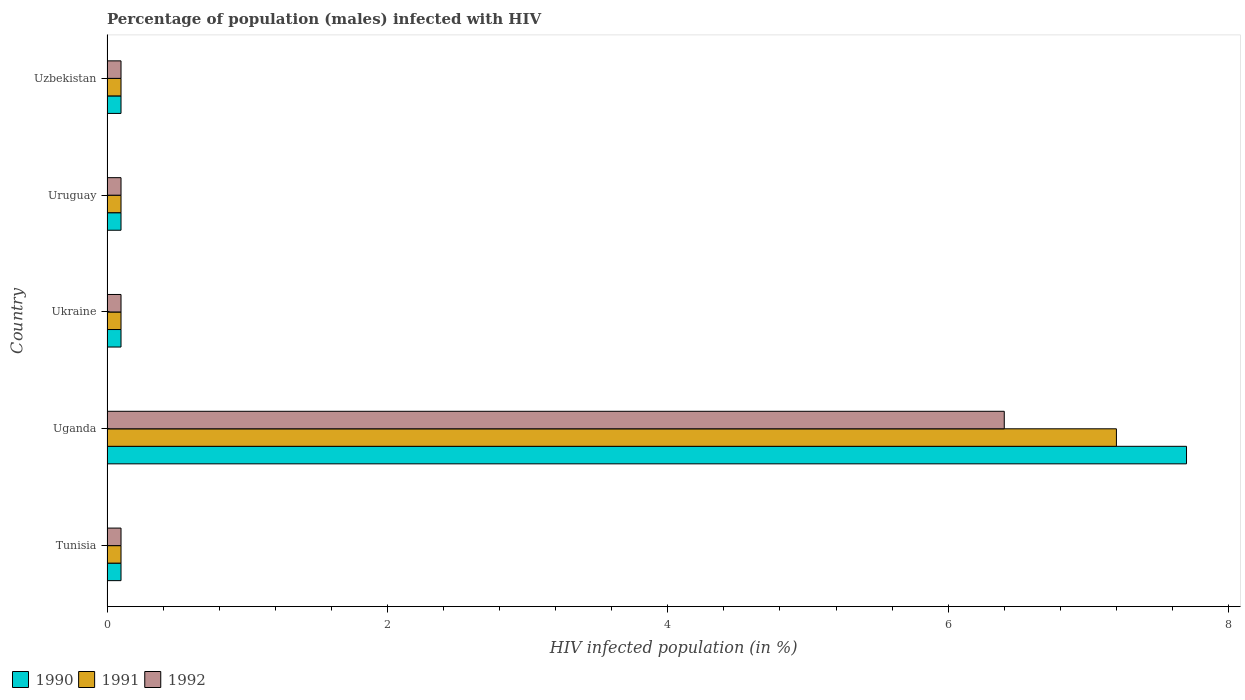How many groups of bars are there?
Offer a terse response. 5. Are the number of bars on each tick of the Y-axis equal?
Make the answer very short. Yes. What is the label of the 3rd group of bars from the top?
Make the answer very short. Ukraine. In how many cases, is the number of bars for a given country not equal to the number of legend labels?
Your response must be concise. 0. What is the percentage of HIV infected male population in 1991 in Uzbekistan?
Your response must be concise. 0.1. Across all countries, what is the maximum percentage of HIV infected male population in 1991?
Keep it short and to the point. 7.2. In which country was the percentage of HIV infected male population in 1990 maximum?
Ensure brevity in your answer.  Uganda. In which country was the percentage of HIV infected male population in 1992 minimum?
Your answer should be very brief. Tunisia. What is the total percentage of HIV infected male population in 1990 in the graph?
Provide a short and direct response. 8.1. What is the difference between the percentage of HIV infected male population in 1990 in Tunisia and that in Ukraine?
Provide a short and direct response. 0. What is the average percentage of HIV infected male population in 1992 per country?
Give a very brief answer. 1.36. In how many countries, is the percentage of HIV infected male population in 1990 greater than 4.4 %?
Ensure brevity in your answer.  1. What is the difference between the highest and the second highest percentage of HIV infected male population in 1991?
Provide a short and direct response. 7.1. What is the difference between the highest and the lowest percentage of HIV infected male population in 1990?
Make the answer very short. 7.6. In how many countries, is the percentage of HIV infected male population in 1991 greater than the average percentage of HIV infected male population in 1991 taken over all countries?
Make the answer very short. 1. Is the sum of the percentage of HIV infected male population in 1990 in Tunisia and Uzbekistan greater than the maximum percentage of HIV infected male population in 1991 across all countries?
Keep it short and to the point. No. What does the 2nd bar from the top in Uzbekistan represents?
Provide a succinct answer. 1991. What does the 1st bar from the bottom in Uganda represents?
Give a very brief answer. 1990. Are all the bars in the graph horizontal?
Keep it short and to the point. Yes. How many countries are there in the graph?
Your answer should be very brief. 5. What is the difference between two consecutive major ticks on the X-axis?
Offer a terse response. 2. Does the graph contain any zero values?
Your answer should be compact. No. What is the title of the graph?
Offer a terse response. Percentage of population (males) infected with HIV. Does "1967" appear as one of the legend labels in the graph?
Offer a very short reply. No. What is the label or title of the X-axis?
Your response must be concise. HIV infected population (in %). What is the label or title of the Y-axis?
Your answer should be compact. Country. What is the HIV infected population (in %) of 1990 in Tunisia?
Your response must be concise. 0.1. What is the HIV infected population (in %) of 1991 in Tunisia?
Your answer should be very brief. 0.1. What is the HIV infected population (in %) in 1992 in Tunisia?
Ensure brevity in your answer.  0.1. What is the HIV infected population (in %) in 1991 in Uganda?
Give a very brief answer. 7.2. What is the HIV infected population (in %) of 1992 in Uganda?
Provide a succinct answer. 6.4. What is the HIV infected population (in %) of 1992 in Ukraine?
Provide a succinct answer. 0.1. What is the HIV infected population (in %) of 1990 in Uruguay?
Offer a very short reply. 0.1. What is the HIV infected population (in %) of 1991 in Uruguay?
Provide a succinct answer. 0.1. What is the HIV infected population (in %) of 1992 in Uruguay?
Your answer should be very brief. 0.1. What is the HIV infected population (in %) of 1990 in Uzbekistan?
Offer a very short reply. 0.1. Across all countries, what is the maximum HIV infected population (in %) in 1992?
Make the answer very short. 6.4. Across all countries, what is the minimum HIV infected population (in %) in 1990?
Make the answer very short. 0.1. Across all countries, what is the minimum HIV infected population (in %) of 1991?
Keep it short and to the point. 0.1. What is the total HIV infected population (in %) in 1990 in the graph?
Offer a very short reply. 8.1. What is the total HIV infected population (in %) in 1991 in the graph?
Provide a succinct answer. 7.6. What is the total HIV infected population (in %) in 1992 in the graph?
Give a very brief answer. 6.8. What is the difference between the HIV infected population (in %) in 1990 in Tunisia and that in Ukraine?
Provide a succinct answer. 0. What is the difference between the HIV infected population (in %) in 1991 in Tunisia and that in Uruguay?
Provide a succinct answer. 0. What is the difference between the HIV infected population (in %) of 1992 in Tunisia and that in Uruguay?
Your answer should be very brief. 0. What is the difference between the HIV infected population (in %) of 1991 in Tunisia and that in Uzbekistan?
Your answer should be compact. 0. What is the difference between the HIV infected population (in %) of 1990 in Uganda and that in Ukraine?
Provide a short and direct response. 7.6. What is the difference between the HIV infected population (in %) in 1991 in Uganda and that in Ukraine?
Keep it short and to the point. 7.1. What is the difference between the HIV infected population (in %) of 1992 in Uganda and that in Ukraine?
Your answer should be very brief. 6.3. What is the difference between the HIV infected population (in %) in 1990 in Uganda and that in Uruguay?
Keep it short and to the point. 7.6. What is the difference between the HIV infected population (in %) in 1991 in Uganda and that in Uruguay?
Offer a very short reply. 7.1. What is the difference between the HIV infected population (in %) of 1992 in Uganda and that in Uruguay?
Provide a succinct answer. 6.3. What is the difference between the HIV infected population (in %) of 1991 in Uganda and that in Uzbekistan?
Offer a very short reply. 7.1. What is the difference between the HIV infected population (in %) in 1992 in Ukraine and that in Uruguay?
Give a very brief answer. 0. What is the difference between the HIV infected population (in %) in 1990 in Ukraine and that in Uzbekistan?
Your answer should be very brief. 0. What is the difference between the HIV infected population (in %) of 1990 in Tunisia and the HIV infected population (in %) of 1991 in Uganda?
Provide a succinct answer. -7.1. What is the difference between the HIV infected population (in %) of 1990 in Tunisia and the HIV infected population (in %) of 1992 in Uganda?
Make the answer very short. -6.3. What is the difference between the HIV infected population (in %) of 1991 in Tunisia and the HIV infected population (in %) of 1992 in Uganda?
Your answer should be very brief. -6.3. What is the difference between the HIV infected population (in %) of 1990 in Tunisia and the HIV infected population (in %) of 1991 in Ukraine?
Keep it short and to the point. 0. What is the difference between the HIV infected population (in %) in 1990 in Tunisia and the HIV infected population (in %) in 1992 in Ukraine?
Offer a very short reply. 0. What is the difference between the HIV infected population (in %) in 1991 in Tunisia and the HIV infected population (in %) in 1992 in Ukraine?
Provide a short and direct response. 0. What is the difference between the HIV infected population (in %) of 1990 in Tunisia and the HIV infected population (in %) of 1992 in Uruguay?
Offer a very short reply. 0. What is the difference between the HIV infected population (in %) of 1991 in Tunisia and the HIV infected population (in %) of 1992 in Uruguay?
Keep it short and to the point. 0. What is the difference between the HIV infected population (in %) in 1990 in Tunisia and the HIV infected population (in %) in 1991 in Uzbekistan?
Your answer should be very brief. 0. What is the difference between the HIV infected population (in %) in 1991 in Tunisia and the HIV infected population (in %) in 1992 in Uzbekistan?
Offer a very short reply. 0. What is the difference between the HIV infected population (in %) in 1990 in Uganda and the HIV infected population (in %) in 1992 in Ukraine?
Ensure brevity in your answer.  7.6. What is the difference between the HIV infected population (in %) of 1991 in Uganda and the HIV infected population (in %) of 1992 in Ukraine?
Your answer should be compact. 7.1. What is the difference between the HIV infected population (in %) in 1990 in Uganda and the HIV infected population (in %) in 1992 in Uruguay?
Keep it short and to the point. 7.6. What is the difference between the HIV infected population (in %) in 1991 in Uganda and the HIV infected population (in %) in 1992 in Uruguay?
Provide a short and direct response. 7.1. What is the difference between the HIV infected population (in %) in 1990 in Uganda and the HIV infected population (in %) in 1991 in Uzbekistan?
Offer a terse response. 7.6. What is the difference between the HIV infected population (in %) of 1990 in Ukraine and the HIV infected population (in %) of 1991 in Uzbekistan?
Make the answer very short. 0. What is the difference between the HIV infected population (in %) in 1990 in Ukraine and the HIV infected population (in %) in 1992 in Uzbekistan?
Keep it short and to the point. 0. What is the difference between the HIV infected population (in %) of 1990 in Uruguay and the HIV infected population (in %) of 1992 in Uzbekistan?
Offer a terse response. 0. What is the average HIV infected population (in %) in 1990 per country?
Ensure brevity in your answer.  1.62. What is the average HIV infected population (in %) of 1991 per country?
Keep it short and to the point. 1.52. What is the average HIV infected population (in %) of 1992 per country?
Provide a succinct answer. 1.36. What is the difference between the HIV infected population (in %) of 1990 and HIV infected population (in %) of 1991 in Tunisia?
Offer a very short reply. 0. What is the difference between the HIV infected population (in %) in 1991 and HIV infected population (in %) in 1992 in Tunisia?
Keep it short and to the point. 0. What is the difference between the HIV infected population (in %) of 1990 and HIV infected population (in %) of 1991 in Uganda?
Your answer should be very brief. 0.5. What is the difference between the HIV infected population (in %) of 1991 and HIV infected population (in %) of 1992 in Uganda?
Keep it short and to the point. 0.8. What is the difference between the HIV infected population (in %) of 1990 and HIV infected population (in %) of 1991 in Ukraine?
Provide a succinct answer. 0. What is the difference between the HIV infected population (in %) of 1990 and HIV infected population (in %) of 1992 in Ukraine?
Your answer should be very brief. 0. What is the difference between the HIV infected population (in %) in 1990 and HIV infected population (in %) in 1991 in Uruguay?
Keep it short and to the point. 0. What is the difference between the HIV infected population (in %) in 1990 and HIV infected population (in %) in 1992 in Uruguay?
Keep it short and to the point. 0. What is the difference between the HIV infected population (in %) in 1990 and HIV infected population (in %) in 1991 in Uzbekistan?
Offer a terse response. 0. What is the ratio of the HIV infected population (in %) of 1990 in Tunisia to that in Uganda?
Offer a very short reply. 0.01. What is the ratio of the HIV infected population (in %) in 1991 in Tunisia to that in Uganda?
Offer a terse response. 0.01. What is the ratio of the HIV infected population (in %) of 1992 in Tunisia to that in Uganda?
Your answer should be compact. 0.02. What is the ratio of the HIV infected population (in %) of 1991 in Tunisia to that in Ukraine?
Ensure brevity in your answer.  1. What is the ratio of the HIV infected population (in %) in 1990 in Tunisia to that in Uruguay?
Offer a terse response. 1. What is the ratio of the HIV infected population (in %) of 1991 in Tunisia to that in Uzbekistan?
Keep it short and to the point. 1. What is the ratio of the HIV infected population (in %) in 1990 in Uganda to that in Uruguay?
Your response must be concise. 77. What is the ratio of the HIV infected population (in %) in 1992 in Uganda to that in Uruguay?
Give a very brief answer. 64. What is the ratio of the HIV infected population (in %) of 1991 in Uganda to that in Uzbekistan?
Your response must be concise. 72. What is the ratio of the HIV infected population (in %) in 1991 in Ukraine to that in Uruguay?
Your response must be concise. 1. What is the ratio of the HIV infected population (in %) of 1991 in Ukraine to that in Uzbekistan?
Offer a very short reply. 1. What is the ratio of the HIV infected population (in %) of 1990 in Uruguay to that in Uzbekistan?
Give a very brief answer. 1. What is the ratio of the HIV infected population (in %) of 1991 in Uruguay to that in Uzbekistan?
Your answer should be very brief. 1. What is the ratio of the HIV infected population (in %) of 1992 in Uruguay to that in Uzbekistan?
Provide a succinct answer. 1. What is the difference between the highest and the second highest HIV infected population (in %) in 1990?
Provide a short and direct response. 7.6. What is the difference between the highest and the second highest HIV infected population (in %) in 1992?
Keep it short and to the point. 6.3. What is the difference between the highest and the lowest HIV infected population (in %) of 1992?
Your response must be concise. 6.3. 